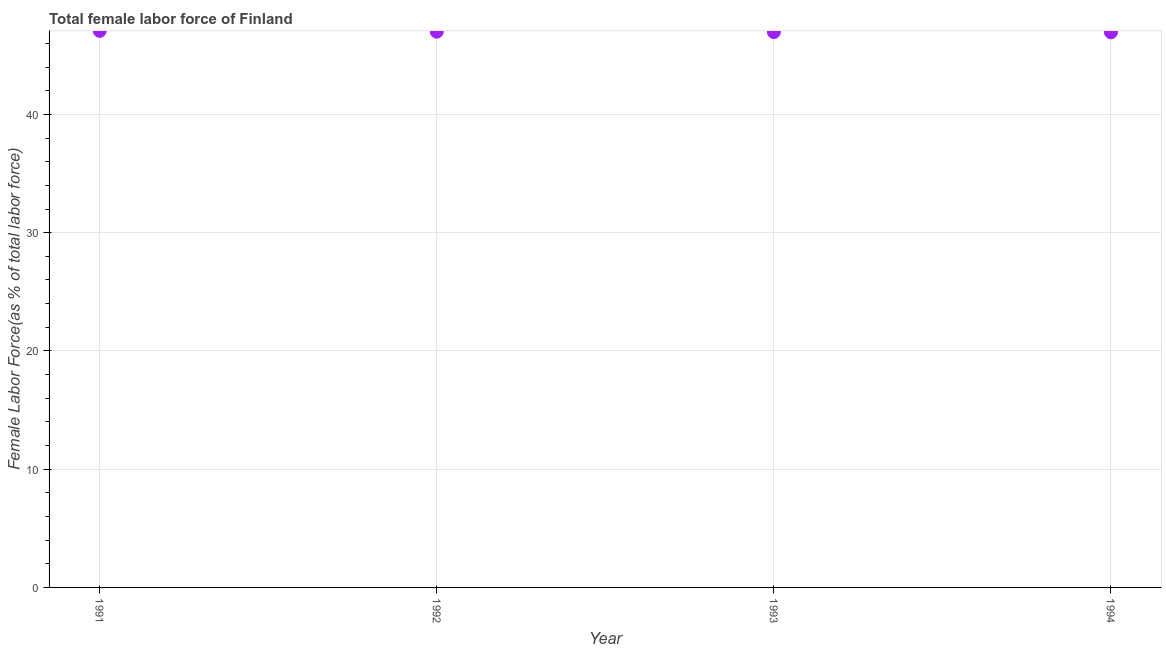What is the total female labor force in 1994?
Offer a terse response. 46.95. Across all years, what is the maximum total female labor force?
Keep it short and to the point. 47.07. Across all years, what is the minimum total female labor force?
Your response must be concise. 46.95. In which year was the total female labor force maximum?
Give a very brief answer. 1991. What is the sum of the total female labor force?
Your answer should be compact. 187.97. What is the difference between the total female labor force in 1991 and 1994?
Your answer should be compact. 0.12. What is the average total female labor force per year?
Ensure brevity in your answer.  46.99. What is the median total female labor force?
Make the answer very short. 46.98. In how many years, is the total female labor force greater than 42 %?
Offer a very short reply. 4. Do a majority of the years between 1994 and 1992 (inclusive) have total female labor force greater than 44 %?
Provide a short and direct response. No. What is the ratio of the total female labor force in 1991 to that in 1992?
Your answer should be compact. 1. Is the total female labor force in 1992 less than that in 1993?
Keep it short and to the point. No. Is the difference between the total female labor force in 1993 and 1994 greater than the difference between any two years?
Provide a succinct answer. No. What is the difference between the highest and the second highest total female labor force?
Offer a very short reply. 0.07. What is the difference between the highest and the lowest total female labor force?
Give a very brief answer. 0.12. In how many years, is the total female labor force greater than the average total female labor force taken over all years?
Give a very brief answer. 2. How many dotlines are there?
Give a very brief answer. 1. How many years are there in the graph?
Offer a very short reply. 4. Are the values on the major ticks of Y-axis written in scientific E-notation?
Offer a terse response. No. What is the title of the graph?
Your response must be concise. Total female labor force of Finland. What is the label or title of the Y-axis?
Give a very brief answer. Female Labor Force(as % of total labor force). What is the Female Labor Force(as % of total labor force) in 1991?
Make the answer very short. 47.07. What is the Female Labor Force(as % of total labor force) in 1992?
Keep it short and to the point. 47. What is the Female Labor Force(as % of total labor force) in 1993?
Make the answer very short. 46.97. What is the Female Labor Force(as % of total labor force) in 1994?
Make the answer very short. 46.95. What is the difference between the Female Labor Force(as % of total labor force) in 1991 and 1992?
Offer a terse response. 0.07. What is the difference between the Female Labor Force(as % of total labor force) in 1991 and 1993?
Ensure brevity in your answer.  0.1. What is the difference between the Female Labor Force(as % of total labor force) in 1991 and 1994?
Your answer should be compact. 0.12. What is the difference between the Female Labor Force(as % of total labor force) in 1992 and 1993?
Offer a terse response. 0.03. What is the difference between the Female Labor Force(as % of total labor force) in 1992 and 1994?
Provide a short and direct response. 0.05. What is the difference between the Female Labor Force(as % of total labor force) in 1993 and 1994?
Make the answer very short. 0.02. What is the ratio of the Female Labor Force(as % of total labor force) in 1991 to that in 1992?
Your answer should be very brief. 1. What is the ratio of the Female Labor Force(as % of total labor force) in 1992 to that in 1994?
Your answer should be very brief. 1. 